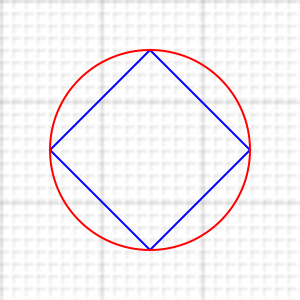In Islamic geometric patterns, an octagon is often used as a central motif. Given a square with side length $a$, what is the area of the largest regular octagon that can be inscribed within this square, expressed in terms of $a$? To solve this problem, let's follow these steps:

1) First, we need to visualize the octagon inscribed in the square. The octagon's vertices touch the midpoints of the square's sides.

2) The octagon can be divided into 8 congruent triangles. Let's focus on one of these triangles.

3) This triangle has a base that's half the side of the square (so $\frac{a}{2}$), and its height is half the diagonal of the square.

4) The diagonal of the square can be calculated using the Pythagorean theorem: $d = a\sqrt{2}$

5) So, the height of our triangle is $\frac{a\sqrt{2}}{4}$

6) The area of this triangle is:

   $A_{triangle} = \frac{1}{2} \cdot \frac{a}{2} \cdot \frac{a\sqrt{2}}{4} = \frac{a^2\sqrt{2}}{16}$

7) Since there are 8 of these triangles in the octagon, the total area is:

   $A_{octagon} = 8 \cdot \frac{a^2\sqrt{2}}{16} = \frac{a^2\sqrt{2}}{2}$

8) This can be simplified to: $A_{octagon} = (\sqrt{2} - 1)a^2$

Therefore, the area of the largest regular octagon that can be inscribed in a square with side length $a$ is $(\sqrt{2} - 1)a^2$.
Answer: $(\sqrt{2} - 1)a^2$ 